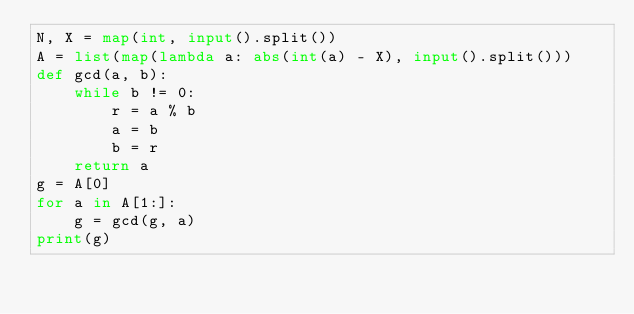Convert code to text. <code><loc_0><loc_0><loc_500><loc_500><_Python_>N, X = map(int, input().split())
A = list(map(lambda a: abs(int(a) - X), input().split()))
def gcd(a, b):
    while b != 0:
        r = a % b
        a = b
        b = r
    return a
g = A[0]
for a in A[1:]:
    g = gcd(g, a)
print(g)
</code> 